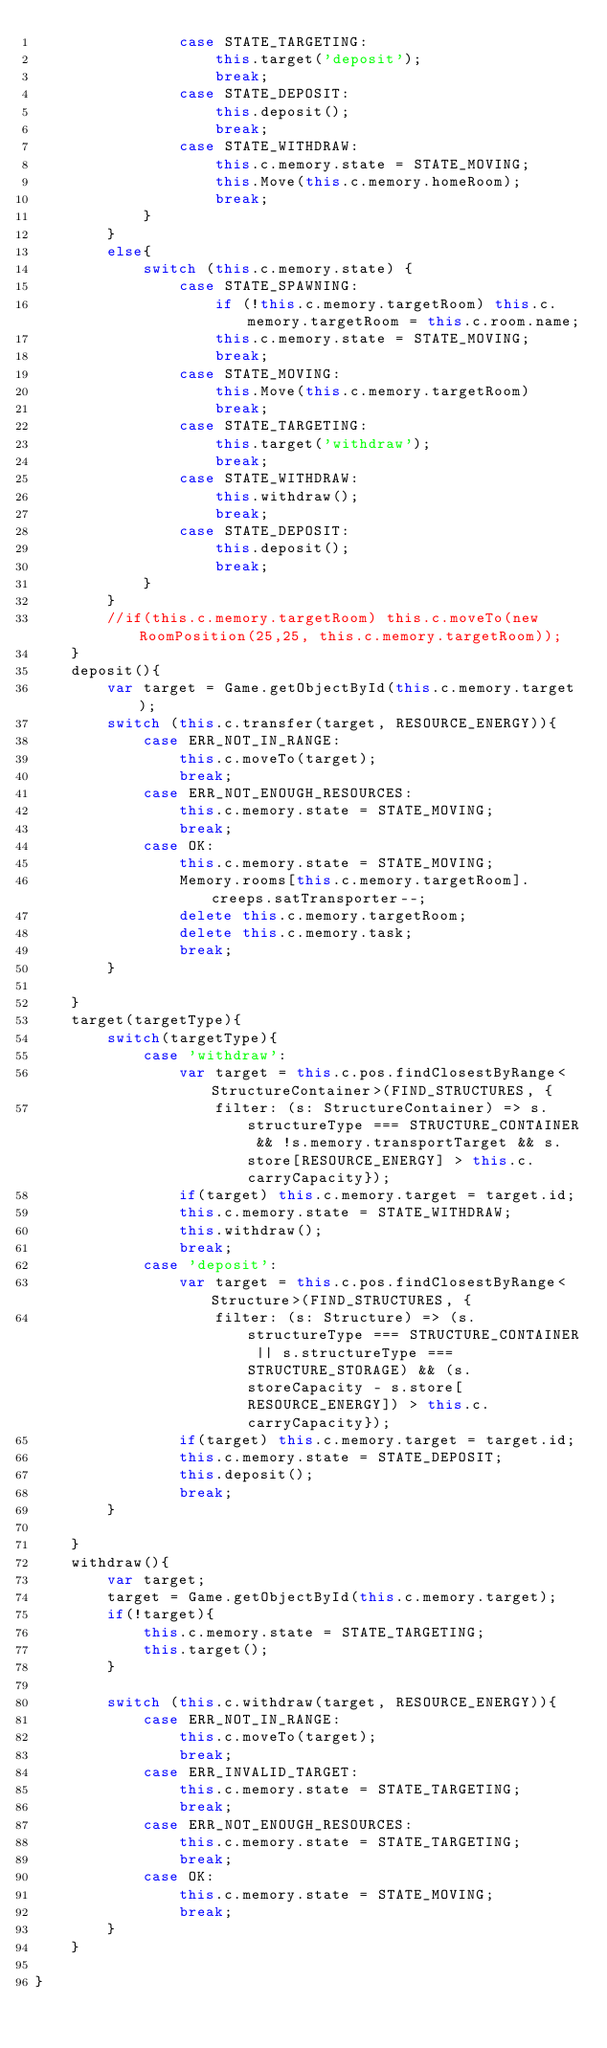<code> <loc_0><loc_0><loc_500><loc_500><_TypeScript_>                case STATE_TARGETING:
                    this.target('deposit');
                    break;
                case STATE_DEPOSIT:
                    this.deposit();
                    break;
                case STATE_WITHDRAW:
                    this.c.memory.state = STATE_MOVING;
                    this.Move(this.c.memory.homeRoom);
                    break;
            }
        }
        else{
            switch (this.c.memory.state) {
                case STATE_SPAWNING:
                    if (!this.c.memory.targetRoom) this.c.memory.targetRoom = this.c.room.name;
                    this.c.memory.state = STATE_MOVING;
                    break;
                case STATE_MOVING:
                    this.Move(this.c.memory.targetRoom)
                    break;
                case STATE_TARGETING:
                    this.target('withdraw');
                    break;
                case STATE_WITHDRAW:
                    this.withdraw();
                    break;
                case STATE_DEPOSIT:
                    this.deposit();
                    break;
            }
        }
        //if(this.c.memory.targetRoom) this.c.moveTo(new RoomPosition(25,25, this.c.memory.targetRoom));
    }
    deposit(){
        var target = Game.getObjectById(this.c.memory.target);
        switch (this.c.transfer(target, RESOURCE_ENERGY)){
            case ERR_NOT_IN_RANGE:
                this.c.moveTo(target);
                break;
            case ERR_NOT_ENOUGH_RESOURCES:
                this.c.memory.state = STATE_MOVING;
                break;
            case OK:
                this.c.memory.state = STATE_MOVING;
                Memory.rooms[this.c.memory.targetRoom].creeps.satTransporter--;
                delete this.c.memory.targetRoom;
                delete this.c.memory.task;
                break;
        }

    }
    target(targetType){
        switch(targetType){
            case 'withdraw':
                var target = this.c.pos.findClosestByRange<StructureContainer>(FIND_STRUCTURES, {
                    filter: (s: StructureContainer) => s.structureType === STRUCTURE_CONTAINER && !s.memory.transportTarget && s.store[RESOURCE_ENERGY] > this.c.carryCapacity});
                if(target) this.c.memory.target = target.id;
                this.c.memory.state = STATE_WITHDRAW;
                this.withdraw();
                break;
            case 'deposit':
                var target = this.c.pos.findClosestByRange<Structure>(FIND_STRUCTURES, {
                    filter: (s: Structure) => (s.structureType === STRUCTURE_CONTAINER || s.structureType === STRUCTURE_STORAGE) && (s.storeCapacity - s.store[RESOURCE_ENERGY]) > this.c.carryCapacity});
                if(target) this.c.memory.target = target.id;
                this.c.memory.state = STATE_DEPOSIT;
                this.deposit();
                break;
        }

    }
    withdraw(){
        var target;
        target = Game.getObjectById(this.c.memory.target);
        if(!target){
            this.c.memory.state = STATE_TARGETING;
            this.target();
        }

        switch (this.c.withdraw(target, RESOURCE_ENERGY)){
            case ERR_NOT_IN_RANGE:
                this.c.moveTo(target);
                break;
            case ERR_INVALID_TARGET:
                this.c.memory.state = STATE_TARGETING;
                break;
            case ERR_NOT_ENOUGH_RESOURCES:
                this.c.memory.state = STATE_TARGETING;
                break;
            case OK:
                this.c.memory.state = STATE_MOVING;
                break;
        }
    }

}
</code> 